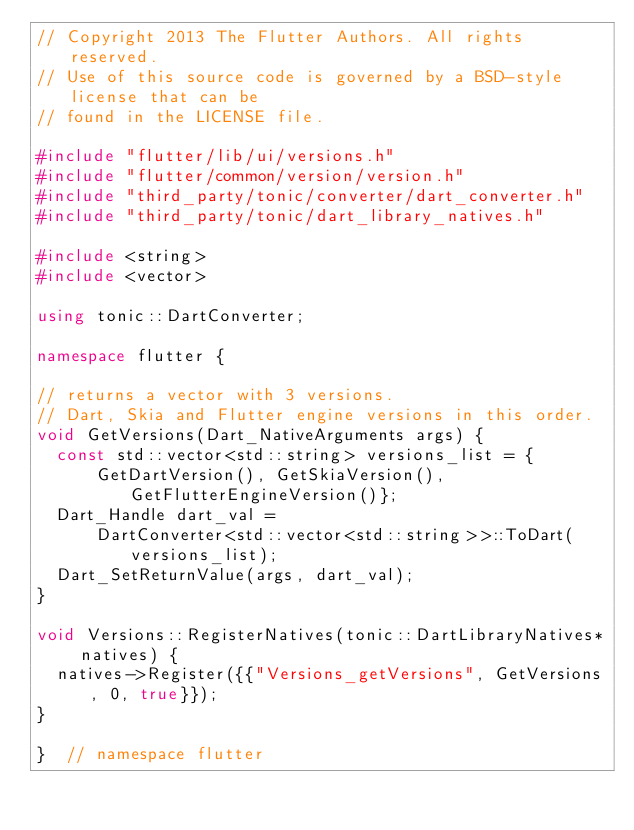Convert code to text. <code><loc_0><loc_0><loc_500><loc_500><_C++_>// Copyright 2013 The Flutter Authors. All rights reserved.
// Use of this source code is governed by a BSD-style license that can be
// found in the LICENSE file.

#include "flutter/lib/ui/versions.h"
#include "flutter/common/version/version.h"
#include "third_party/tonic/converter/dart_converter.h"
#include "third_party/tonic/dart_library_natives.h"

#include <string>
#include <vector>

using tonic::DartConverter;

namespace flutter {

// returns a vector with 3 versions.
// Dart, Skia and Flutter engine versions in this order.
void GetVersions(Dart_NativeArguments args) {
  const std::vector<std::string> versions_list = {
      GetDartVersion(), GetSkiaVersion(), GetFlutterEngineVersion()};
  Dart_Handle dart_val =
      DartConverter<std::vector<std::string>>::ToDart(versions_list);
  Dart_SetReturnValue(args, dart_val);
}

void Versions::RegisterNatives(tonic::DartLibraryNatives* natives) {
  natives->Register({{"Versions_getVersions", GetVersions, 0, true}});
}

}  // namespace flutter
</code> 